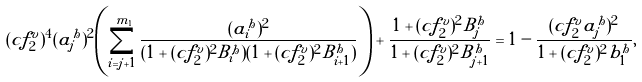<formula> <loc_0><loc_0><loc_500><loc_500>( c f _ { 2 } ^ { v } ) ^ { 4 } ( a _ { j } ^ { h } ) ^ { 2 } \left ( \sum _ { i = j + 1 } ^ { m _ { 1 } } \frac { ( a _ { i } ^ { h } ) ^ { 2 } } { ( 1 + ( c f _ { 2 } ^ { v } ) ^ { 2 } B _ { i } ^ { h } ) ( 1 + ( c f _ { 2 } ^ { v } ) ^ { 2 } B _ { i + 1 } ^ { h } ) } \right ) + \frac { 1 + ( c f _ { 2 } ^ { v } ) ^ { 2 } B _ { j } ^ { h } } { 1 + ( c f _ { 2 } ^ { v } ) ^ { 2 } B _ { j + 1 } ^ { h } } = 1 - \frac { ( c f _ { 2 } ^ { v } a _ { j } ^ { h } ) ^ { 2 } } { 1 + ( c f _ { 2 } ^ { v } ) ^ { 2 } b _ { 1 } ^ { h } } ,</formula> 